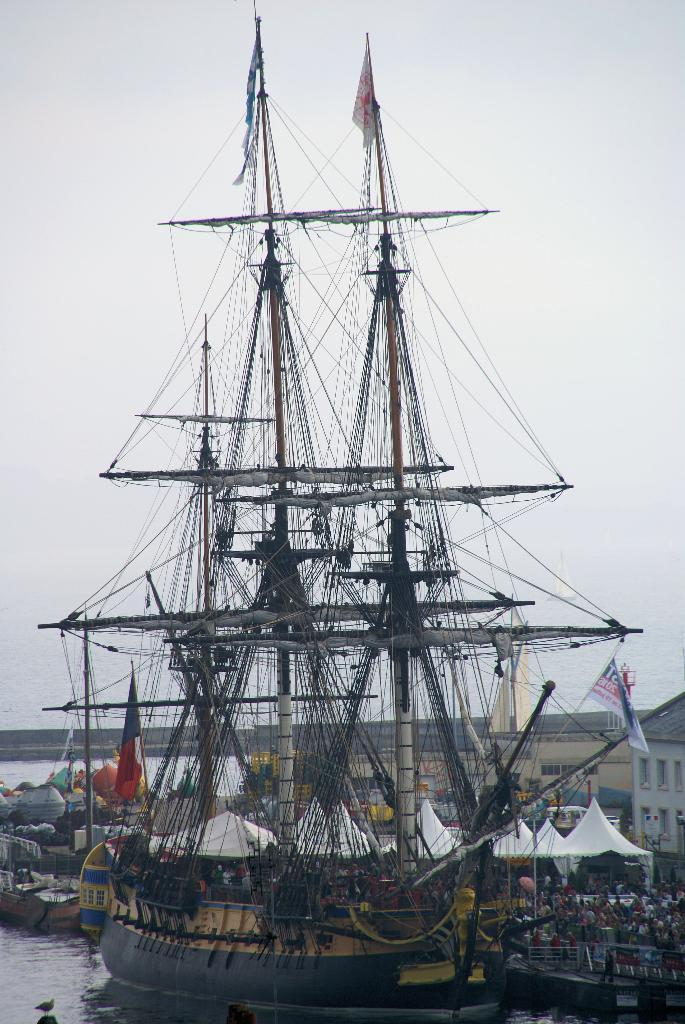What is floating on the water in the image? There is a ship floating on the water in the image. What type of structures can be seen on land in the image? There are tents and buildings in the image. What is visible at the top of the image? The sky is visible at the top of the image. Where is the start button for the ship located in the image? There is no start button for the ship in the image, as ships are not operated by buttons. 